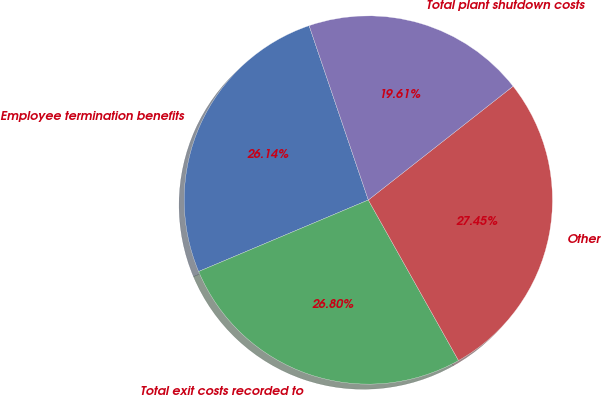Convert chart to OTSL. <chart><loc_0><loc_0><loc_500><loc_500><pie_chart><fcel>Employee termination benefits<fcel>Total exit costs recorded to<fcel>Other<fcel>Total plant shutdown costs<nl><fcel>26.14%<fcel>26.8%<fcel>27.45%<fcel>19.61%<nl></chart> 